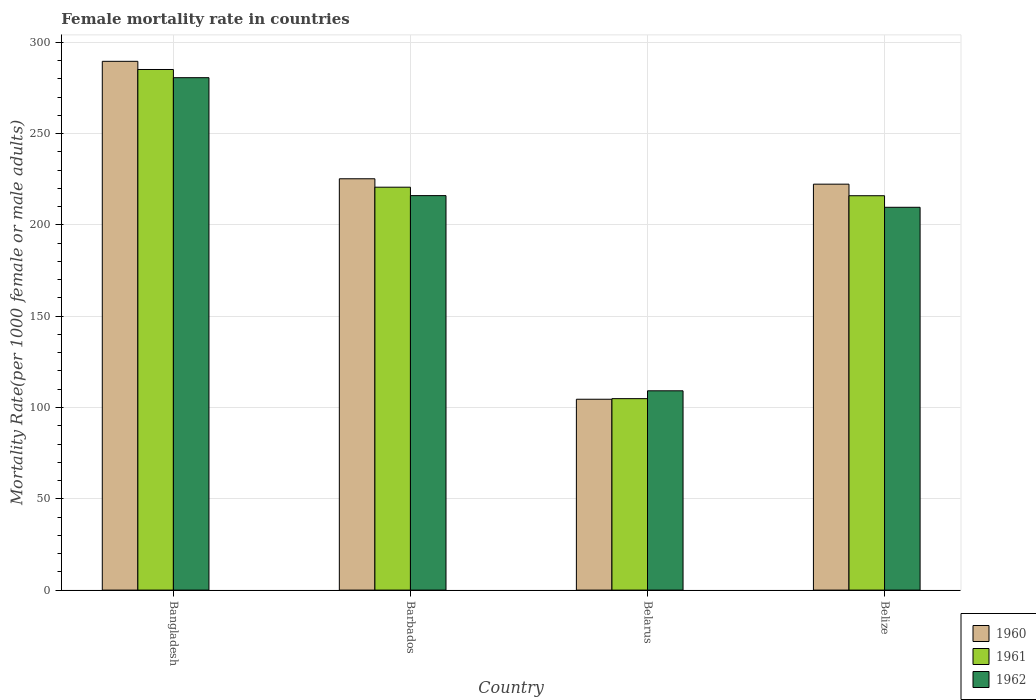Are the number of bars on each tick of the X-axis equal?
Give a very brief answer. Yes. What is the female mortality rate in 1960 in Bangladesh?
Offer a very short reply. 289.55. Across all countries, what is the maximum female mortality rate in 1961?
Ensure brevity in your answer.  285.07. Across all countries, what is the minimum female mortality rate in 1960?
Your answer should be very brief. 104.51. In which country was the female mortality rate in 1960 maximum?
Your answer should be compact. Bangladesh. In which country was the female mortality rate in 1960 minimum?
Ensure brevity in your answer.  Belarus. What is the total female mortality rate in 1960 in the graph?
Make the answer very short. 841.57. What is the difference between the female mortality rate in 1960 in Bangladesh and that in Barbados?
Your answer should be very brief. 64.32. What is the difference between the female mortality rate in 1960 in Belize and the female mortality rate in 1961 in Belarus?
Your response must be concise. 117.44. What is the average female mortality rate in 1961 per country?
Ensure brevity in your answer.  206.62. What is the difference between the female mortality rate of/in 1962 and female mortality rate of/in 1961 in Belarus?
Ensure brevity in your answer.  4.29. What is the ratio of the female mortality rate in 1961 in Bangladesh to that in Barbados?
Offer a terse response. 1.29. What is the difference between the highest and the second highest female mortality rate in 1961?
Your answer should be compact. -64.45. What is the difference between the highest and the lowest female mortality rate in 1962?
Offer a very short reply. 171.46. In how many countries, is the female mortality rate in 1960 greater than the average female mortality rate in 1960 taken over all countries?
Offer a terse response. 3. What does the 3rd bar from the left in Barbados represents?
Keep it short and to the point. 1962. What does the 3rd bar from the right in Bangladesh represents?
Ensure brevity in your answer.  1960. Is it the case that in every country, the sum of the female mortality rate in 1960 and female mortality rate in 1961 is greater than the female mortality rate in 1962?
Your answer should be compact. Yes. How many bars are there?
Ensure brevity in your answer.  12. Are all the bars in the graph horizontal?
Provide a succinct answer. No. What is the difference between two consecutive major ticks on the Y-axis?
Make the answer very short. 50. Are the values on the major ticks of Y-axis written in scientific E-notation?
Offer a terse response. No. Does the graph contain any zero values?
Provide a short and direct response. No. Does the graph contain grids?
Make the answer very short. Yes. Where does the legend appear in the graph?
Provide a succinct answer. Bottom right. How many legend labels are there?
Provide a succinct answer. 3. How are the legend labels stacked?
Ensure brevity in your answer.  Vertical. What is the title of the graph?
Your response must be concise. Female mortality rate in countries. Does "1997" appear as one of the legend labels in the graph?
Offer a terse response. No. What is the label or title of the X-axis?
Ensure brevity in your answer.  Country. What is the label or title of the Y-axis?
Give a very brief answer. Mortality Rate(per 1000 female or male adults). What is the Mortality Rate(per 1000 female or male adults) in 1960 in Bangladesh?
Your response must be concise. 289.55. What is the Mortality Rate(per 1000 female or male adults) in 1961 in Bangladesh?
Provide a succinct answer. 285.07. What is the Mortality Rate(per 1000 female or male adults) in 1962 in Bangladesh?
Ensure brevity in your answer.  280.59. What is the Mortality Rate(per 1000 female or male adults) in 1960 in Barbados?
Offer a terse response. 225.23. What is the Mortality Rate(per 1000 female or male adults) of 1961 in Barbados?
Provide a short and direct response. 220.62. What is the Mortality Rate(per 1000 female or male adults) in 1962 in Barbados?
Ensure brevity in your answer.  216.01. What is the Mortality Rate(per 1000 female or male adults) in 1960 in Belarus?
Offer a very short reply. 104.51. What is the Mortality Rate(per 1000 female or male adults) in 1961 in Belarus?
Provide a short and direct response. 104.84. What is the Mortality Rate(per 1000 female or male adults) in 1962 in Belarus?
Ensure brevity in your answer.  109.13. What is the Mortality Rate(per 1000 female or male adults) of 1960 in Belize?
Offer a very short reply. 222.28. What is the Mortality Rate(per 1000 female or male adults) in 1961 in Belize?
Give a very brief answer. 215.95. What is the Mortality Rate(per 1000 female or male adults) of 1962 in Belize?
Offer a very short reply. 209.62. Across all countries, what is the maximum Mortality Rate(per 1000 female or male adults) of 1960?
Offer a terse response. 289.55. Across all countries, what is the maximum Mortality Rate(per 1000 female or male adults) in 1961?
Your answer should be compact. 285.07. Across all countries, what is the maximum Mortality Rate(per 1000 female or male adults) of 1962?
Provide a short and direct response. 280.59. Across all countries, what is the minimum Mortality Rate(per 1000 female or male adults) in 1960?
Make the answer very short. 104.51. Across all countries, what is the minimum Mortality Rate(per 1000 female or male adults) of 1961?
Provide a succinct answer. 104.84. Across all countries, what is the minimum Mortality Rate(per 1000 female or male adults) in 1962?
Your response must be concise. 109.13. What is the total Mortality Rate(per 1000 female or male adults) of 1960 in the graph?
Provide a short and direct response. 841.57. What is the total Mortality Rate(per 1000 female or male adults) in 1961 in the graph?
Give a very brief answer. 826.48. What is the total Mortality Rate(per 1000 female or male adults) of 1962 in the graph?
Ensure brevity in your answer.  815.35. What is the difference between the Mortality Rate(per 1000 female or male adults) in 1960 in Bangladesh and that in Barbados?
Ensure brevity in your answer.  64.32. What is the difference between the Mortality Rate(per 1000 female or male adults) of 1961 in Bangladesh and that in Barbados?
Offer a very short reply. 64.45. What is the difference between the Mortality Rate(per 1000 female or male adults) of 1962 in Bangladesh and that in Barbados?
Your answer should be compact. 64.58. What is the difference between the Mortality Rate(per 1000 female or male adults) in 1960 in Bangladesh and that in Belarus?
Ensure brevity in your answer.  185.04. What is the difference between the Mortality Rate(per 1000 female or male adults) of 1961 in Bangladesh and that in Belarus?
Offer a terse response. 180.23. What is the difference between the Mortality Rate(per 1000 female or male adults) in 1962 in Bangladesh and that in Belarus?
Make the answer very short. 171.46. What is the difference between the Mortality Rate(per 1000 female or male adults) in 1960 in Bangladesh and that in Belize?
Your answer should be compact. 67.27. What is the difference between the Mortality Rate(per 1000 female or male adults) of 1961 in Bangladesh and that in Belize?
Provide a succinct answer. 69.12. What is the difference between the Mortality Rate(per 1000 female or male adults) of 1962 in Bangladesh and that in Belize?
Give a very brief answer. 70.97. What is the difference between the Mortality Rate(per 1000 female or male adults) in 1960 in Barbados and that in Belarus?
Give a very brief answer. 120.72. What is the difference between the Mortality Rate(per 1000 female or male adults) in 1961 in Barbados and that in Belarus?
Your answer should be compact. 115.78. What is the difference between the Mortality Rate(per 1000 female or male adults) of 1962 in Barbados and that in Belarus?
Keep it short and to the point. 106.88. What is the difference between the Mortality Rate(per 1000 female or male adults) in 1960 in Barbados and that in Belize?
Provide a short and direct response. 2.95. What is the difference between the Mortality Rate(per 1000 female or male adults) in 1961 in Barbados and that in Belize?
Your answer should be very brief. 4.67. What is the difference between the Mortality Rate(per 1000 female or male adults) in 1962 in Barbados and that in Belize?
Offer a very short reply. 6.39. What is the difference between the Mortality Rate(per 1000 female or male adults) in 1960 in Belarus and that in Belize?
Provide a succinct answer. -117.77. What is the difference between the Mortality Rate(per 1000 female or male adults) in 1961 in Belarus and that in Belize?
Offer a terse response. -111.11. What is the difference between the Mortality Rate(per 1000 female or male adults) in 1962 in Belarus and that in Belize?
Keep it short and to the point. -100.49. What is the difference between the Mortality Rate(per 1000 female or male adults) in 1960 in Bangladesh and the Mortality Rate(per 1000 female or male adults) in 1961 in Barbados?
Provide a succinct answer. 68.93. What is the difference between the Mortality Rate(per 1000 female or male adults) in 1960 in Bangladesh and the Mortality Rate(per 1000 female or male adults) in 1962 in Barbados?
Make the answer very short. 73.54. What is the difference between the Mortality Rate(per 1000 female or male adults) in 1961 in Bangladesh and the Mortality Rate(per 1000 female or male adults) in 1962 in Barbados?
Give a very brief answer. 69.06. What is the difference between the Mortality Rate(per 1000 female or male adults) of 1960 in Bangladesh and the Mortality Rate(per 1000 female or male adults) of 1961 in Belarus?
Your answer should be very brief. 184.71. What is the difference between the Mortality Rate(per 1000 female or male adults) in 1960 in Bangladesh and the Mortality Rate(per 1000 female or male adults) in 1962 in Belarus?
Your answer should be very brief. 180.42. What is the difference between the Mortality Rate(per 1000 female or male adults) in 1961 in Bangladesh and the Mortality Rate(per 1000 female or male adults) in 1962 in Belarus?
Provide a short and direct response. 175.94. What is the difference between the Mortality Rate(per 1000 female or male adults) in 1960 in Bangladesh and the Mortality Rate(per 1000 female or male adults) in 1961 in Belize?
Ensure brevity in your answer.  73.6. What is the difference between the Mortality Rate(per 1000 female or male adults) in 1960 in Bangladesh and the Mortality Rate(per 1000 female or male adults) in 1962 in Belize?
Provide a succinct answer. 79.93. What is the difference between the Mortality Rate(per 1000 female or male adults) in 1961 in Bangladesh and the Mortality Rate(per 1000 female or male adults) in 1962 in Belize?
Offer a terse response. 75.45. What is the difference between the Mortality Rate(per 1000 female or male adults) in 1960 in Barbados and the Mortality Rate(per 1000 female or male adults) in 1961 in Belarus?
Keep it short and to the point. 120.39. What is the difference between the Mortality Rate(per 1000 female or male adults) in 1960 in Barbados and the Mortality Rate(per 1000 female or male adults) in 1962 in Belarus?
Keep it short and to the point. 116.1. What is the difference between the Mortality Rate(per 1000 female or male adults) of 1961 in Barbados and the Mortality Rate(per 1000 female or male adults) of 1962 in Belarus?
Keep it short and to the point. 111.49. What is the difference between the Mortality Rate(per 1000 female or male adults) in 1960 in Barbados and the Mortality Rate(per 1000 female or male adults) in 1961 in Belize?
Offer a terse response. 9.28. What is the difference between the Mortality Rate(per 1000 female or male adults) of 1960 in Barbados and the Mortality Rate(per 1000 female or male adults) of 1962 in Belize?
Make the answer very short. 15.61. What is the difference between the Mortality Rate(per 1000 female or male adults) in 1961 in Barbados and the Mortality Rate(per 1000 female or male adults) in 1962 in Belize?
Keep it short and to the point. 11. What is the difference between the Mortality Rate(per 1000 female or male adults) in 1960 in Belarus and the Mortality Rate(per 1000 female or male adults) in 1961 in Belize?
Give a very brief answer. -111.44. What is the difference between the Mortality Rate(per 1000 female or male adults) of 1960 in Belarus and the Mortality Rate(per 1000 female or male adults) of 1962 in Belize?
Your answer should be compact. -105.11. What is the difference between the Mortality Rate(per 1000 female or male adults) in 1961 in Belarus and the Mortality Rate(per 1000 female or male adults) in 1962 in Belize?
Your answer should be compact. -104.78. What is the average Mortality Rate(per 1000 female or male adults) in 1960 per country?
Offer a very short reply. 210.39. What is the average Mortality Rate(per 1000 female or male adults) in 1961 per country?
Ensure brevity in your answer.  206.62. What is the average Mortality Rate(per 1000 female or male adults) in 1962 per country?
Your answer should be compact. 203.84. What is the difference between the Mortality Rate(per 1000 female or male adults) of 1960 and Mortality Rate(per 1000 female or male adults) of 1961 in Bangladesh?
Offer a terse response. 4.48. What is the difference between the Mortality Rate(per 1000 female or male adults) in 1960 and Mortality Rate(per 1000 female or male adults) in 1962 in Bangladesh?
Provide a succinct answer. 8.96. What is the difference between the Mortality Rate(per 1000 female or male adults) of 1961 and Mortality Rate(per 1000 female or male adults) of 1962 in Bangladesh?
Provide a short and direct response. 4.48. What is the difference between the Mortality Rate(per 1000 female or male adults) in 1960 and Mortality Rate(per 1000 female or male adults) in 1961 in Barbados?
Your answer should be very brief. 4.61. What is the difference between the Mortality Rate(per 1000 female or male adults) of 1960 and Mortality Rate(per 1000 female or male adults) of 1962 in Barbados?
Ensure brevity in your answer.  9.22. What is the difference between the Mortality Rate(per 1000 female or male adults) of 1961 and Mortality Rate(per 1000 female or male adults) of 1962 in Barbados?
Ensure brevity in your answer.  4.61. What is the difference between the Mortality Rate(per 1000 female or male adults) in 1960 and Mortality Rate(per 1000 female or male adults) in 1961 in Belarus?
Offer a very short reply. -0.33. What is the difference between the Mortality Rate(per 1000 female or male adults) in 1960 and Mortality Rate(per 1000 female or male adults) in 1962 in Belarus?
Offer a very short reply. -4.62. What is the difference between the Mortality Rate(per 1000 female or male adults) in 1961 and Mortality Rate(per 1000 female or male adults) in 1962 in Belarus?
Provide a succinct answer. -4.29. What is the difference between the Mortality Rate(per 1000 female or male adults) in 1960 and Mortality Rate(per 1000 female or male adults) in 1961 in Belize?
Offer a very short reply. 6.33. What is the difference between the Mortality Rate(per 1000 female or male adults) in 1960 and Mortality Rate(per 1000 female or male adults) in 1962 in Belize?
Your response must be concise. 12.66. What is the difference between the Mortality Rate(per 1000 female or male adults) of 1961 and Mortality Rate(per 1000 female or male adults) of 1962 in Belize?
Provide a succinct answer. 6.33. What is the ratio of the Mortality Rate(per 1000 female or male adults) in 1960 in Bangladesh to that in Barbados?
Your answer should be compact. 1.29. What is the ratio of the Mortality Rate(per 1000 female or male adults) in 1961 in Bangladesh to that in Barbados?
Ensure brevity in your answer.  1.29. What is the ratio of the Mortality Rate(per 1000 female or male adults) of 1962 in Bangladesh to that in Barbados?
Your answer should be compact. 1.3. What is the ratio of the Mortality Rate(per 1000 female or male adults) of 1960 in Bangladesh to that in Belarus?
Make the answer very short. 2.77. What is the ratio of the Mortality Rate(per 1000 female or male adults) of 1961 in Bangladesh to that in Belarus?
Ensure brevity in your answer.  2.72. What is the ratio of the Mortality Rate(per 1000 female or male adults) of 1962 in Bangladesh to that in Belarus?
Keep it short and to the point. 2.57. What is the ratio of the Mortality Rate(per 1000 female or male adults) in 1960 in Bangladesh to that in Belize?
Give a very brief answer. 1.3. What is the ratio of the Mortality Rate(per 1000 female or male adults) in 1961 in Bangladesh to that in Belize?
Your answer should be very brief. 1.32. What is the ratio of the Mortality Rate(per 1000 female or male adults) of 1962 in Bangladesh to that in Belize?
Offer a very short reply. 1.34. What is the ratio of the Mortality Rate(per 1000 female or male adults) of 1960 in Barbados to that in Belarus?
Offer a very short reply. 2.16. What is the ratio of the Mortality Rate(per 1000 female or male adults) in 1961 in Barbados to that in Belarus?
Give a very brief answer. 2.1. What is the ratio of the Mortality Rate(per 1000 female or male adults) of 1962 in Barbados to that in Belarus?
Provide a short and direct response. 1.98. What is the ratio of the Mortality Rate(per 1000 female or male adults) in 1960 in Barbados to that in Belize?
Make the answer very short. 1.01. What is the ratio of the Mortality Rate(per 1000 female or male adults) of 1961 in Barbados to that in Belize?
Offer a terse response. 1.02. What is the ratio of the Mortality Rate(per 1000 female or male adults) of 1962 in Barbados to that in Belize?
Your answer should be compact. 1.03. What is the ratio of the Mortality Rate(per 1000 female or male adults) in 1960 in Belarus to that in Belize?
Give a very brief answer. 0.47. What is the ratio of the Mortality Rate(per 1000 female or male adults) of 1961 in Belarus to that in Belize?
Your response must be concise. 0.49. What is the ratio of the Mortality Rate(per 1000 female or male adults) in 1962 in Belarus to that in Belize?
Provide a succinct answer. 0.52. What is the difference between the highest and the second highest Mortality Rate(per 1000 female or male adults) of 1960?
Your response must be concise. 64.32. What is the difference between the highest and the second highest Mortality Rate(per 1000 female or male adults) of 1961?
Your answer should be compact. 64.45. What is the difference between the highest and the second highest Mortality Rate(per 1000 female or male adults) in 1962?
Give a very brief answer. 64.58. What is the difference between the highest and the lowest Mortality Rate(per 1000 female or male adults) in 1960?
Make the answer very short. 185.04. What is the difference between the highest and the lowest Mortality Rate(per 1000 female or male adults) in 1961?
Your answer should be compact. 180.23. What is the difference between the highest and the lowest Mortality Rate(per 1000 female or male adults) in 1962?
Offer a very short reply. 171.46. 